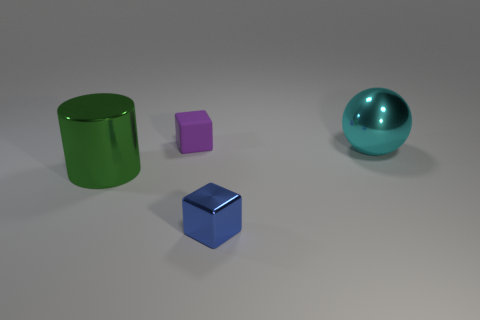Add 2 small blue things. How many objects exist? 6 Subtract all cylinders. How many objects are left? 3 Subtract all green shiny cylinders. Subtract all yellow matte objects. How many objects are left? 3 Add 3 large cyan metal objects. How many large cyan metal objects are left? 4 Add 2 small cyan spheres. How many small cyan spheres exist? 2 Subtract 1 blue blocks. How many objects are left? 3 